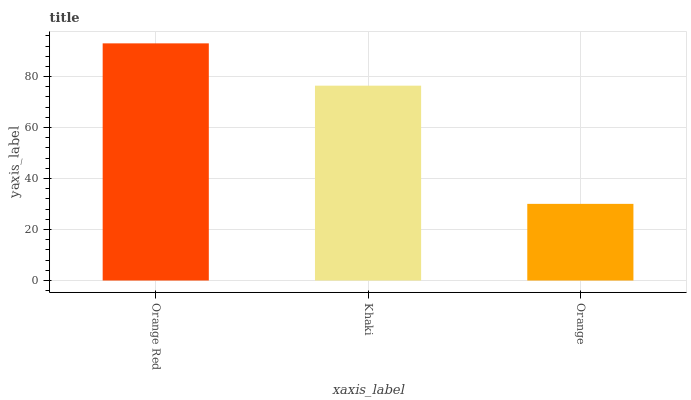Is Khaki the minimum?
Answer yes or no. No. Is Khaki the maximum?
Answer yes or no. No. Is Orange Red greater than Khaki?
Answer yes or no. Yes. Is Khaki less than Orange Red?
Answer yes or no. Yes. Is Khaki greater than Orange Red?
Answer yes or no. No. Is Orange Red less than Khaki?
Answer yes or no. No. Is Khaki the high median?
Answer yes or no. Yes. Is Khaki the low median?
Answer yes or no. Yes. Is Orange the high median?
Answer yes or no. No. Is Orange Red the low median?
Answer yes or no. No. 